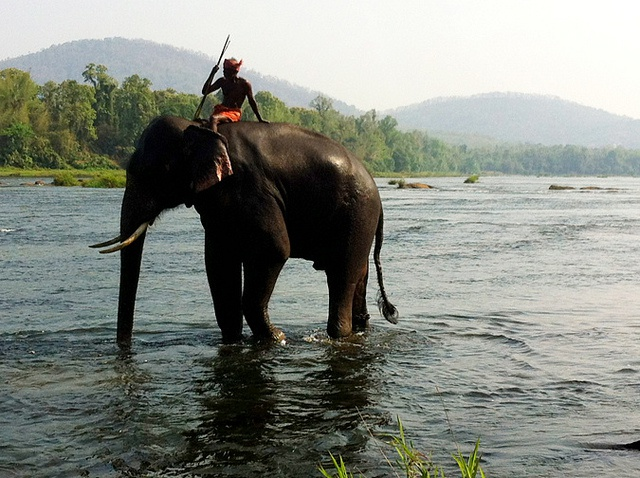Describe the objects in this image and their specific colors. I can see elephant in lightgray, black, darkgray, gray, and maroon tones and people in lightgray, black, maroon, gray, and brown tones in this image. 